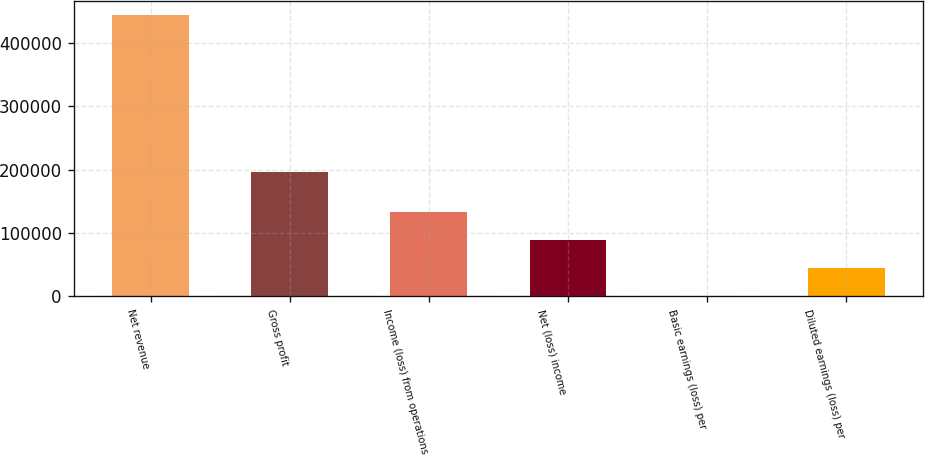<chart> <loc_0><loc_0><loc_500><loc_500><bar_chart><fcel>Net revenue<fcel>Gross profit<fcel>Income (loss) from operations<fcel>Net (loss) income<fcel>Basic earnings (loss) per<fcel>Diluted earnings (loss) per<nl><fcel>443562<fcel>197014<fcel>133069<fcel>88712.4<fcel>0.03<fcel>44356.2<nl></chart> 